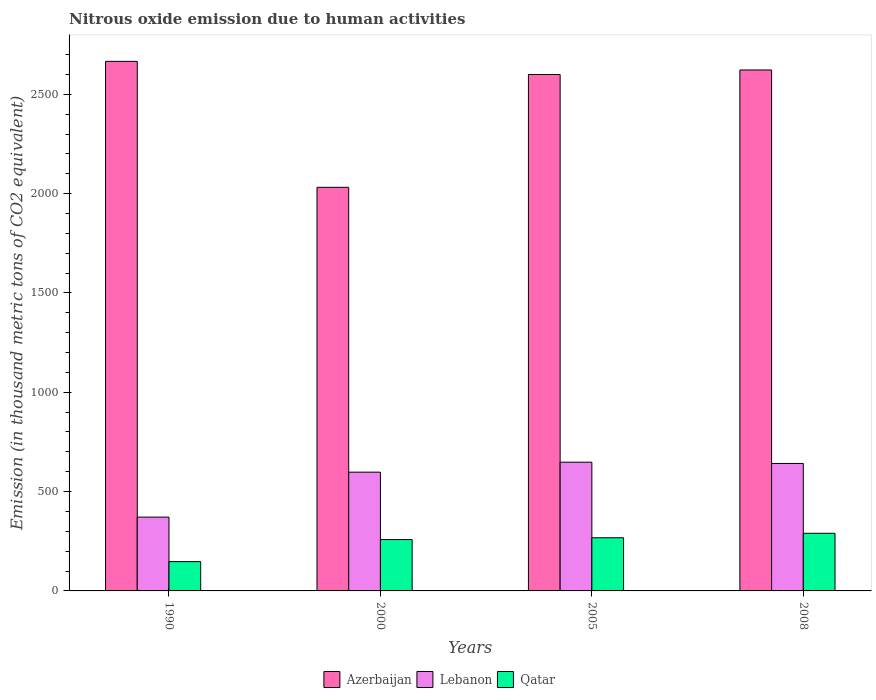Are the number of bars per tick equal to the number of legend labels?
Your answer should be compact. Yes. Are the number of bars on each tick of the X-axis equal?
Your answer should be compact. Yes. In how many cases, is the number of bars for a given year not equal to the number of legend labels?
Give a very brief answer. 0. What is the amount of nitrous oxide emitted in Azerbaijan in 2000?
Make the answer very short. 2031.7. Across all years, what is the maximum amount of nitrous oxide emitted in Azerbaijan?
Provide a succinct answer. 2665.8. Across all years, what is the minimum amount of nitrous oxide emitted in Azerbaijan?
Ensure brevity in your answer.  2031.7. In which year was the amount of nitrous oxide emitted in Azerbaijan maximum?
Provide a short and direct response. 1990. What is the total amount of nitrous oxide emitted in Azerbaijan in the graph?
Provide a short and direct response. 9919.5. What is the difference between the amount of nitrous oxide emitted in Qatar in 2005 and that in 2008?
Your response must be concise. -22.5. What is the difference between the amount of nitrous oxide emitted in Qatar in 2008 and the amount of nitrous oxide emitted in Lebanon in 1990?
Offer a terse response. -81.5. What is the average amount of nitrous oxide emitted in Azerbaijan per year?
Your response must be concise. 2479.88. In the year 2008, what is the difference between the amount of nitrous oxide emitted in Lebanon and amount of nitrous oxide emitted in Qatar?
Your answer should be very brief. 351.5. In how many years, is the amount of nitrous oxide emitted in Lebanon greater than 1900 thousand metric tons?
Give a very brief answer. 0. What is the ratio of the amount of nitrous oxide emitted in Azerbaijan in 2000 to that in 2005?
Ensure brevity in your answer.  0.78. What is the difference between the highest and the second highest amount of nitrous oxide emitted in Azerbaijan?
Make the answer very short. 43.4. What is the difference between the highest and the lowest amount of nitrous oxide emitted in Lebanon?
Keep it short and to the point. 276.4. Is the sum of the amount of nitrous oxide emitted in Azerbaijan in 1990 and 2008 greater than the maximum amount of nitrous oxide emitted in Lebanon across all years?
Provide a succinct answer. Yes. What does the 3rd bar from the left in 1990 represents?
Keep it short and to the point. Qatar. What does the 3rd bar from the right in 2005 represents?
Your response must be concise. Azerbaijan. Is it the case that in every year, the sum of the amount of nitrous oxide emitted in Lebanon and amount of nitrous oxide emitted in Qatar is greater than the amount of nitrous oxide emitted in Azerbaijan?
Your answer should be very brief. No. How many bars are there?
Your answer should be compact. 12. Are all the bars in the graph horizontal?
Make the answer very short. No. How many years are there in the graph?
Provide a succinct answer. 4. Does the graph contain grids?
Offer a very short reply. No. How many legend labels are there?
Give a very brief answer. 3. How are the legend labels stacked?
Your response must be concise. Horizontal. What is the title of the graph?
Ensure brevity in your answer.  Nitrous oxide emission due to human activities. Does "Malaysia" appear as one of the legend labels in the graph?
Your response must be concise. No. What is the label or title of the Y-axis?
Your response must be concise. Emission (in thousand metric tons of CO2 equivalent). What is the Emission (in thousand metric tons of CO2 equivalent) in Azerbaijan in 1990?
Provide a succinct answer. 2665.8. What is the Emission (in thousand metric tons of CO2 equivalent) of Lebanon in 1990?
Give a very brief answer. 371.6. What is the Emission (in thousand metric tons of CO2 equivalent) of Qatar in 1990?
Provide a succinct answer. 147.6. What is the Emission (in thousand metric tons of CO2 equivalent) of Azerbaijan in 2000?
Give a very brief answer. 2031.7. What is the Emission (in thousand metric tons of CO2 equivalent) of Lebanon in 2000?
Ensure brevity in your answer.  597.8. What is the Emission (in thousand metric tons of CO2 equivalent) in Qatar in 2000?
Offer a very short reply. 258.6. What is the Emission (in thousand metric tons of CO2 equivalent) of Azerbaijan in 2005?
Your answer should be very brief. 2599.6. What is the Emission (in thousand metric tons of CO2 equivalent) in Lebanon in 2005?
Make the answer very short. 648. What is the Emission (in thousand metric tons of CO2 equivalent) in Qatar in 2005?
Provide a succinct answer. 267.6. What is the Emission (in thousand metric tons of CO2 equivalent) of Azerbaijan in 2008?
Ensure brevity in your answer.  2622.4. What is the Emission (in thousand metric tons of CO2 equivalent) of Lebanon in 2008?
Offer a terse response. 641.6. What is the Emission (in thousand metric tons of CO2 equivalent) of Qatar in 2008?
Provide a succinct answer. 290.1. Across all years, what is the maximum Emission (in thousand metric tons of CO2 equivalent) of Azerbaijan?
Make the answer very short. 2665.8. Across all years, what is the maximum Emission (in thousand metric tons of CO2 equivalent) in Lebanon?
Offer a terse response. 648. Across all years, what is the maximum Emission (in thousand metric tons of CO2 equivalent) of Qatar?
Your answer should be compact. 290.1. Across all years, what is the minimum Emission (in thousand metric tons of CO2 equivalent) in Azerbaijan?
Keep it short and to the point. 2031.7. Across all years, what is the minimum Emission (in thousand metric tons of CO2 equivalent) in Lebanon?
Make the answer very short. 371.6. Across all years, what is the minimum Emission (in thousand metric tons of CO2 equivalent) of Qatar?
Offer a terse response. 147.6. What is the total Emission (in thousand metric tons of CO2 equivalent) of Azerbaijan in the graph?
Your answer should be very brief. 9919.5. What is the total Emission (in thousand metric tons of CO2 equivalent) in Lebanon in the graph?
Make the answer very short. 2259. What is the total Emission (in thousand metric tons of CO2 equivalent) in Qatar in the graph?
Keep it short and to the point. 963.9. What is the difference between the Emission (in thousand metric tons of CO2 equivalent) of Azerbaijan in 1990 and that in 2000?
Offer a very short reply. 634.1. What is the difference between the Emission (in thousand metric tons of CO2 equivalent) in Lebanon in 1990 and that in 2000?
Offer a terse response. -226.2. What is the difference between the Emission (in thousand metric tons of CO2 equivalent) of Qatar in 1990 and that in 2000?
Provide a short and direct response. -111. What is the difference between the Emission (in thousand metric tons of CO2 equivalent) of Azerbaijan in 1990 and that in 2005?
Offer a terse response. 66.2. What is the difference between the Emission (in thousand metric tons of CO2 equivalent) in Lebanon in 1990 and that in 2005?
Provide a succinct answer. -276.4. What is the difference between the Emission (in thousand metric tons of CO2 equivalent) of Qatar in 1990 and that in 2005?
Your answer should be very brief. -120. What is the difference between the Emission (in thousand metric tons of CO2 equivalent) of Azerbaijan in 1990 and that in 2008?
Offer a terse response. 43.4. What is the difference between the Emission (in thousand metric tons of CO2 equivalent) of Lebanon in 1990 and that in 2008?
Make the answer very short. -270. What is the difference between the Emission (in thousand metric tons of CO2 equivalent) in Qatar in 1990 and that in 2008?
Ensure brevity in your answer.  -142.5. What is the difference between the Emission (in thousand metric tons of CO2 equivalent) in Azerbaijan in 2000 and that in 2005?
Offer a very short reply. -567.9. What is the difference between the Emission (in thousand metric tons of CO2 equivalent) of Lebanon in 2000 and that in 2005?
Provide a succinct answer. -50.2. What is the difference between the Emission (in thousand metric tons of CO2 equivalent) of Qatar in 2000 and that in 2005?
Keep it short and to the point. -9. What is the difference between the Emission (in thousand metric tons of CO2 equivalent) in Azerbaijan in 2000 and that in 2008?
Your answer should be compact. -590.7. What is the difference between the Emission (in thousand metric tons of CO2 equivalent) of Lebanon in 2000 and that in 2008?
Ensure brevity in your answer.  -43.8. What is the difference between the Emission (in thousand metric tons of CO2 equivalent) in Qatar in 2000 and that in 2008?
Make the answer very short. -31.5. What is the difference between the Emission (in thousand metric tons of CO2 equivalent) of Azerbaijan in 2005 and that in 2008?
Provide a succinct answer. -22.8. What is the difference between the Emission (in thousand metric tons of CO2 equivalent) in Qatar in 2005 and that in 2008?
Offer a very short reply. -22.5. What is the difference between the Emission (in thousand metric tons of CO2 equivalent) in Azerbaijan in 1990 and the Emission (in thousand metric tons of CO2 equivalent) in Lebanon in 2000?
Your answer should be compact. 2068. What is the difference between the Emission (in thousand metric tons of CO2 equivalent) in Azerbaijan in 1990 and the Emission (in thousand metric tons of CO2 equivalent) in Qatar in 2000?
Ensure brevity in your answer.  2407.2. What is the difference between the Emission (in thousand metric tons of CO2 equivalent) in Lebanon in 1990 and the Emission (in thousand metric tons of CO2 equivalent) in Qatar in 2000?
Give a very brief answer. 113. What is the difference between the Emission (in thousand metric tons of CO2 equivalent) in Azerbaijan in 1990 and the Emission (in thousand metric tons of CO2 equivalent) in Lebanon in 2005?
Provide a short and direct response. 2017.8. What is the difference between the Emission (in thousand metric tons of CO2 equivalent) of Azerbaijan in 1990 and the Emission (in thousand metric tons of CO2 equivalent) of Qatar in 2005?
Ensure brevity in your answer.  2398.2. What is the difference between the Emission (in thousand metric tons of CO2 equivalent) of Lebanon in 1990 and the Emission (in thousand metric tons of CO2 equivalent) of Qatar in 2005?
Offer a terse response. 104. What is the difference between the Emission (in thousand metric tons of CO2 equivalent) in Azerbaijan in 1990 and the Emission (in thousand metric tons of CO2 equivalent) in Lebanon in 2008?
Provide a succinct answer. 2024.2. What is the difference between the Emission (in thousand metric tons of CO2 equivalent) of Azerbaijan in 1990 and the Emission (in thousand metric tons of CO2 equivalent) of Qatar in 2008?
Your answer should be compact. 2375.7. What is the difference between the Emission (in thousand metric tons of CO2 equivalent) in Lebanon in 1990 and the Emission (in thousand metric tons of CO2 equivalent) in Qatar in 2008?
Ensure brevity in your answer.  81.5. What is the difference between the Emission (in thousand metric tons of CO2 equivalent) of Azerbaijan in 2000 and the Emission (in thousand metric tons of CO2 equivalent) of Lebanon in 2005?
Make the answer very short. 1383.7. What is the difference between the Emission (in thousand metric tons of CO2 equivalent) of Azerbaijan in 2000 and the Emission (in thousand metric tons of CO2 equivalent) of Qatar in 2005?
Offer a terse response. 1764.1. What is the difference between the Emission (in thousand metric tons of CO2 equivalent) of Lebanon in 2000 and the Emission (in thousand metric tons of CO2 equivalent) of Qatar in 2005?
Your response must be concise. 330.2. What is the difference between the Emission (in thousand metric tons of CO2 equivalent) in Azerbaijan in 2000 and the Emission (in thousand metric tons of CO2 equivalent) in Lebanon in 2008?
Provide a short and direct response. 1390.1. What is the difference between the Emission (in thousand metric tons of CO2 equivalent) in Azerbaijan in 2000 and the Emission (in thousand metric tons of CO2 equivalent) in Qatar in 2008?
Ensure brevity in your answer.  1741.6. What is the difference between the Emission (in thousand metric tons of CO2 equivalent) of Lebanon in 2000 and the Emission (in thousand metric tons of CO2 equivalent) of Qatar in 2008?
Make the answer very short. 307.7. What is the difference between the Emission (in thousand metric tons of CO2 equivalent) in Azerbaijan in 2005 and the Emission (in thousand metric tons of CO2 equivalent) in Lebanon in 2008?
Your response must be concise. 1958. What is the difference between the Emission (in thousand metric tons of CO2 equivalent) in Azerbaijan in 2005 and the Emission (in thousand metric tons of CO2 equivalent) in Qatar in 2008?
Your response must be concise. 2309.5. What is the difference between the Emission (in thousand metric tons of CO2 equivalent) in Lebanon in 2005 and the Emission (in thousand metric tons of CO2 equivalent) in Qatar in 2008?
Ensure brevity in your answer.  357.9. What is the average Emission (in thousand metric tons of CO2 equivalent) in Azerbaijan per year?
Your answer should be compact. 2479.88. What is the average Emission (in thousand metric tons of CO2 equivalent) of Lebanon per year?
Provide a short and direct response. 564.75. What is the average Emission (in thousand metric tons of CO2 equivalent) in Qatar per year?
Ensure brevity in your answer.  240.97. In the year 1990, what is the difference between the Emission (in thousand metric tons of CO2 equivalent) in Azerbaijan and Emission (in thousand metric tons of CO2 equivalent) in Lebanon?
Offer a very short reply. 2294.2. In the year 1990, what is the difference between the Emission (in thousand metric tons of CO2 equivalent) of Azerbaijan and Emission (in thousand metric tons of CO2 equivalent) of Qatar?
Your response must be concise. 2518.2. In the year 1990, what is the difference between the Emission (in thousand metric tons of CO2 equivalent) of Lebanon and Emission (in thousand metric tons of CO2 equivalent) of Qatar?
Ensure brevity in your answer.  224. In the year 2000, what is the difference between the Emission (in thousand metric tons of CO2 equivalent) of Azerbaijan and Emission (in thousand metric tons of CO2 equivalent) of Lebanon?
Offer a terse response. 1433.9. In the year 2000, what is the difference between the Emission (in thousand metric tons of CO2 equivalent) in Azerbaijan and Emission (in thousand metric tons of CO2 equivalent) in Qatar?
Ensure brevity in your answer.  1773.1. In the year 2000, what is the difference between the Emission (in thousand metric tons of CO2 equivalent) in Lebanon and Emission (in thousand metric tons of CO2 equivalent) in Qatar?
Provide a succinct answer. 339.2. In the year 2005, what is the difference between the Emission (in thousand metric tons of CO2 equivalent) in Azerbaijan and Emission (in thousand metric tons of CO2 equivalent) in Lebanon?
Your response must be concise. 1951.6. In the year 2005, what is the difference between the Emission (in thousand metric tons of CO2 equivalent) of Azerbaijan and Emission (in thousand metric tons of CO2 equivalent) of Qatar?
Your answer should be very brief. 2332. In the year 2005, what is the difference between the Emission (in thousand metric tons of CO2 equivalent) of Lebanon and Emission (in thousand metric tons of CO2 equivalent) of Qatar?
Offer a very short reply. 380.4. In the year 2008, what is the difference between the Emission (in thousand metric tons of CO2 equivalent) of Azerbaijan and Emission (in thousand metric tons of CO2 equivalent) of Lebanon?
Keep it short and to the point. 1980.8. In the year 2008, what is the difference between the Emission (in thousand metric tons of CO2 equivalent) of Azerbaijan and Emission (in thousand metric tons of CO2 equivalent) of Qatar?
Your answer should be very brief. 2332.3. In the year 2008, what is the difference between the Emission (in thousand metric tons of CO2 equivalent) of Lebanon and Emission (in thousand metric tons of CO2 equivalent) of Qatar?
Your answer should be compact. 351.5. What is the ratio of the Emission (in thousand metric tons of CO2 equivalent) in Azerbaijan in 1990 to that in 2000?
Offer a terse response. 1.31. What is the ratio of the Emission (in thousand metric tons of CO2 equivalent) in Lebanon in 1990 to that in 2000?
Make the answer very short. 0.62. What is the ratio of the Emission (in thousand metric tons of CO2 equivalent) in Qatar in 1990 to that in 2000?
Offer a terse response. 0.57. What is the ratio of the Emission (in thousand metric tons of CO2 equivalent) of Azerbaijan in 1990 to that in 2005?
Make the answer very short. 1.03. What is the ratio of the Emission (in thousand metric tons of CO2 equivalent) in Lebanon in 1990 to that in 2005?
Provide a succinct answer. 0.57. What is the ratio of the Emission (in thousand metric tons of CO2 equivalent) of Qatar in 1990 to that in 2005?
Your response must be concise. 0.55. What is the ratio of the Emission (in thousand metric tons of CO2 equivalent) in Azerbaijan in 1990 to that in 2008?
Offer a very short reply. 1.02. What is the ratio of the Emission (in thousand metric tons of CO2 equivalent) in Lebanon in 1990 to that in 2008?
Offer a very short reply. 0.58. What is the ratio of the Emission (in thousand metric tons of CO2 equivalent) in Qatar in 1990 to that in 2008?
Your response must be concise. 0.51. What is the ratio of the Emission (in thousand metric tons of CO2 equivalent) in Azerbaijan in 2000 to that in 2005?
Ensure brevity in your answer.  0.78. What is the ratio of the Emission (in thousand metric tons of CO2 equivalent) of Lebanon in 2000 to that in 2005?
Provide a short and direct response. 0.92. What is the ratio of the Emission (in thousand metric tons of CO2 equivalent) in Qatar in 2000 to that in 2005?
Ensure brevity in your answer.  0.97. What is the ratio of the Emission (in thousand metric tons of CO2 equivalent) of Azerbaijan in 2000 to that in 2008?
Give a very brief answer. 0.77. What is the ratio of the Emission (in thousand metric tons of CO2 equivalent) in Lebanon in 2000 to that in 2008?
Your answer should be compact. 0.93. What is the ratio of the Emission (in thousand metric tons of CO2 equivalent) of Qatar in 2000 to that in 2008?
Offer a very short reply. 0.89. What is the ratio of the Emission (in thousand metric tons of CO2 equivalent) in Azerbaijan in 2005 to that in 2008?
Ensure brevity in your answer.  0.99. What is the ratio of the Emission (in thousand metric tons of CO2 equivalent) in Qatar in 2005 to that in 2008?
Your answer should be compact. 0.92. What is the difference between the highest and the second highest Emission (in thousand metric tons of CO2 equivalent) of Azerbaijan?
Keep it short and to the point. 43.4. What is the difference between the highest and the second highest Emission (in thousand metric tons of CO2 equivalent) of Qatar?
Offer a terse response. 22.5. What is the difference between the highest and the lowest Emission (in thousand metric tons of CO2 equivalent) in Azerbaijan?
Your response must be concise. 634.1. What is the difference between the highest and the lowest Emission (in thousand metric tons of CO2 equivalent) in Lebanon?
Your response must be concise. 276.4. What is the difference between the highest and the lowest Emission (in thousand metric tons of CO2 equivalent) of Qatar?
Offer a terse response. 142.5. 